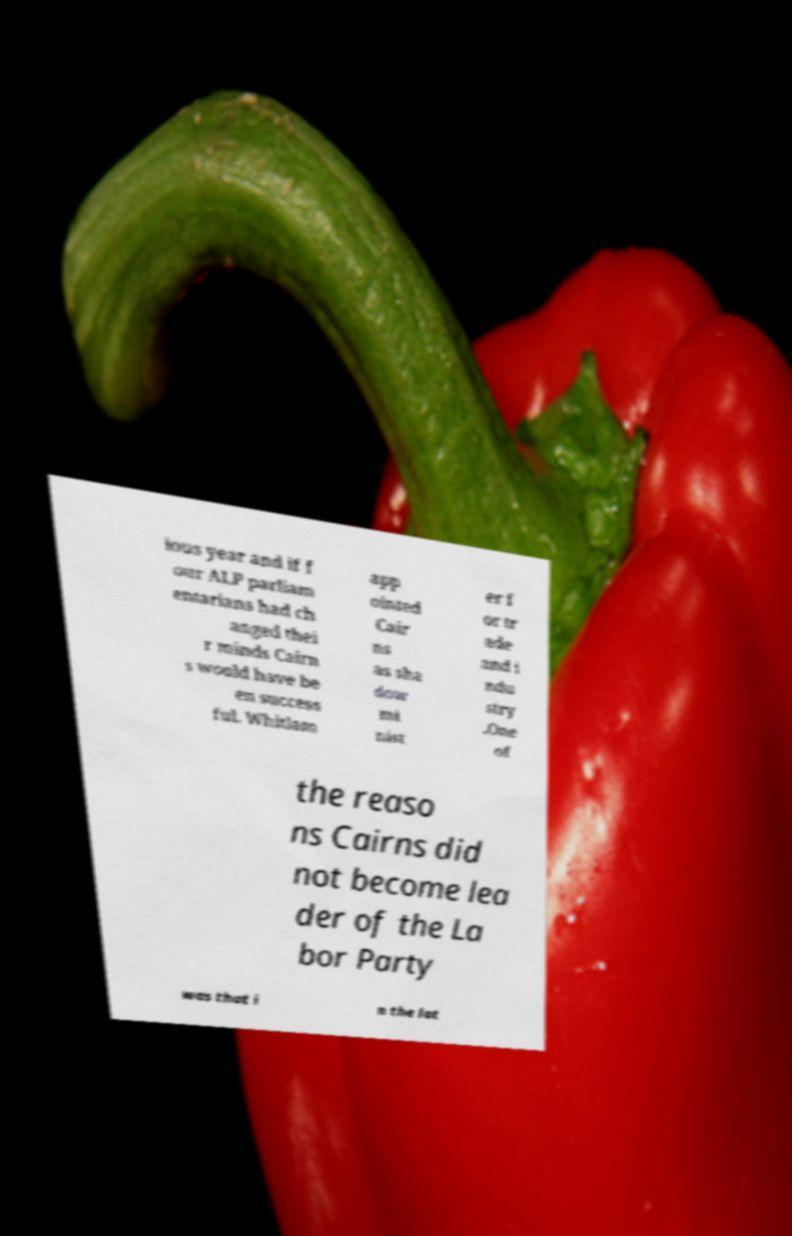Please read and relay the text visible in this image. What does it say? ious year and if f our ALP parliam entarians had ch anged thei r minds Cairn s would have be en success ful. Whitlam app ointed Cair ns as sha dow mi nist er f or tr ade and i ndu stry .One of the reaso ns Cairns did not become lea der of the La bor Party was that i n the lat 